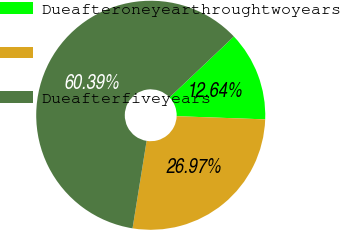<chart> <loc_0><loc_0><loc_500><loc_500><pie_chart><fcel>Dueafteroneyearthroughtwoyears<fcel>Unnamed: 1<fcel>Dueafterfiveyears<nl><fcel>12.64%<fcel>26.97%<fcel>60.39%<nl></chart> 